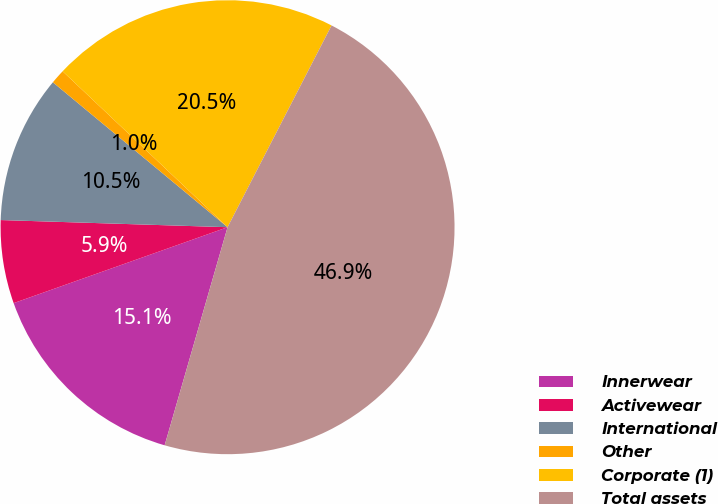<chart> <loc_0><loc_0><loc_500><loc_500><pie_chart><fcel>Innerwear<fcel>Activewear<fcel>International<fcel>Other<fcel>Corporate (1)<fcel>Total assets<nl><fcel>15.1%<fcel>5.93%<fcel>10.52%<fcel>1.03%<fcel>20.52%<fcel>46.89%<nl></chart> 